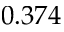Convert formula to latex. <formula><loc_0><loc_0><loc_500><loc_500>0 . 3 7 4</formula> 